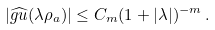Convert formula to latex. <formula><loc_0><loc_0><loc_500><loc_500>| \widehat { g u } ( \lambda \rho _ { a } ) | \leq C _ { m } ( 1 + | \lambda | ) ^ { - m } \, .</formula> 